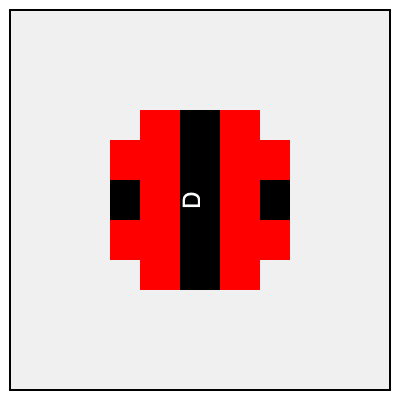Which of the following orientations (A, B, C, or D) correctly represents the flag of Amsterdam? To identify the correct orientation of Amsterdam's flag, follow these steps:

1. Recall that Amsterdam's flag consists of three horizontal stripes: red, black, and red.
2. The black stripe is positioned in the middle and is narrower than the red stripes.
3. Examine each orientation in the image:
   A: Horizontal stripes with red on top and bottom, narrow black stripe in the middle.
   B: Vertical stripes with red on left and right, narrow black stripe in the middle.
   C: Horizontal stripes with red on top and bottom, narrow black stripe in the middle (upside down).
   D: Vertical stripes with red on left and right, narrow black stripe in the middle (rotated 90° counterclockwise).
4. The correct orientation should have horizontal stripes with red on top and bottom.
5. Both A and C meet this criterion, but A is the standard orientation (not upside down).

Therefore, orientation A is the correct representation of Amsterdam's flag.
Answer: A 